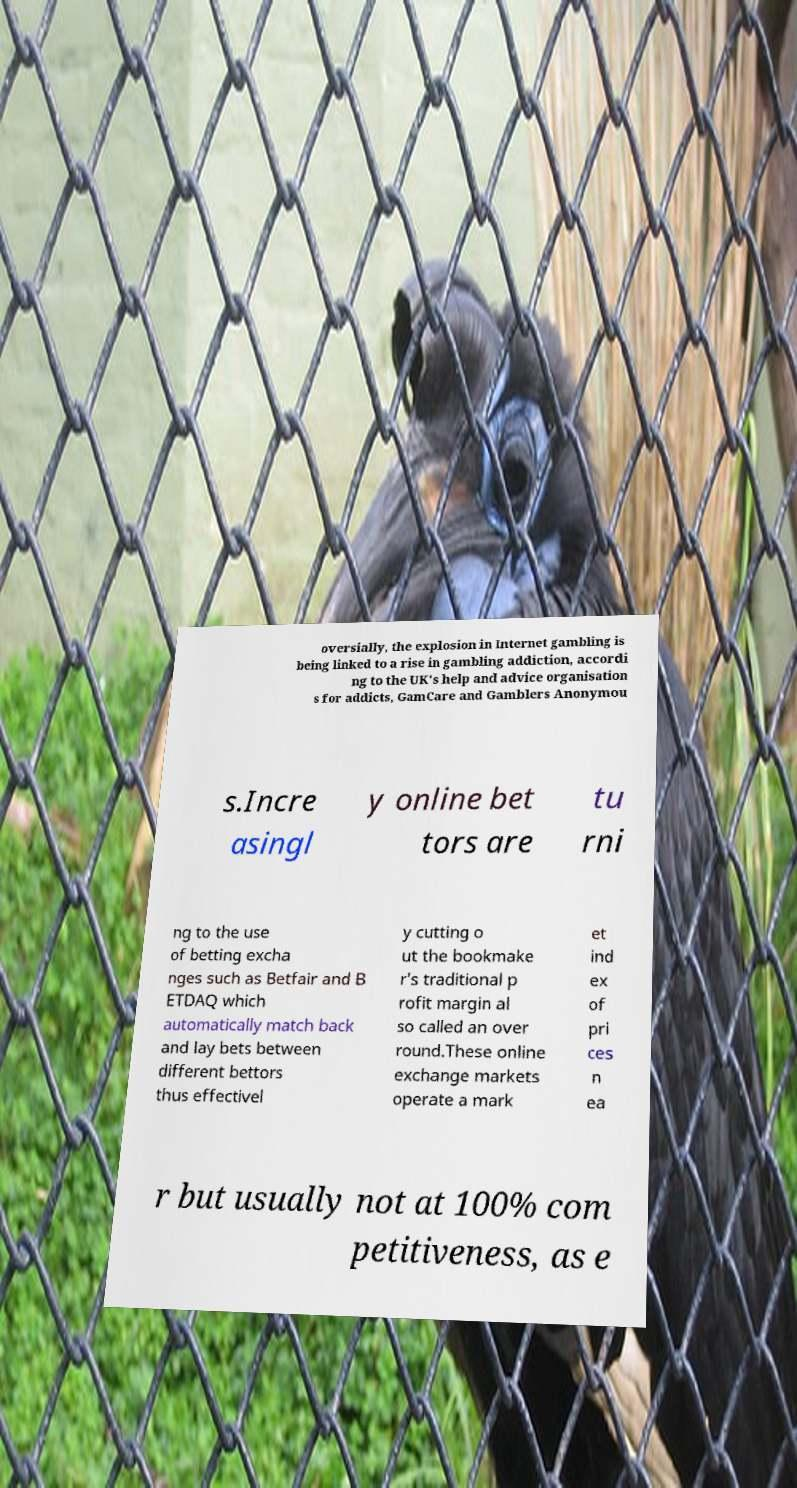There's text embedded in this image that I need extracted. Can you transcribe it verbatim? oversially, the explosion in Internet gambling is being linked to a rise in gambling addiction, accordi ng to the UK's help and advice organisation s for addicts, GamCare and Gamblers Anonymou s.Incre asingl y online bet tors are tu rni ng to the use of betting excha nges such as Betfair and B ETDAQ which automatically match back and lay bets between different bettors thus effectivel y cutting o ut the bookmake r's traditional p rofit margin al so called an over round.These online exchange markets operate a mark et ind ex of pri ces n ea r but usually not at 100% com petitiveness, as e 